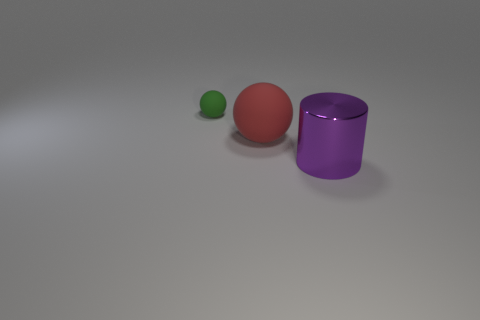Add 3 small things. How many objects exist? 6 Subtract all spheres. How many objects are left? 1 Subtract all small purple rubber blocks. Subtract all green matte balls. How many objects are left? 2 Add 1 small green objects. How many small green objects are left? 2 Add 1 tiny cyan metallic spheres. How many tiny cyan metallic spheres exist? 1 Subtract 0 yellow cylinders. How many objects are left? 3 